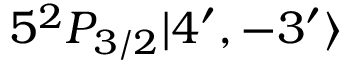Convert formula to latex. <formula><loc_0><loc_0><loc_500><loc_500>5 ^ { 2 } P _ { 3 / 2 } | 4 ^ { \prime } , - 3 ^ { \prime } \rangle</formula> 